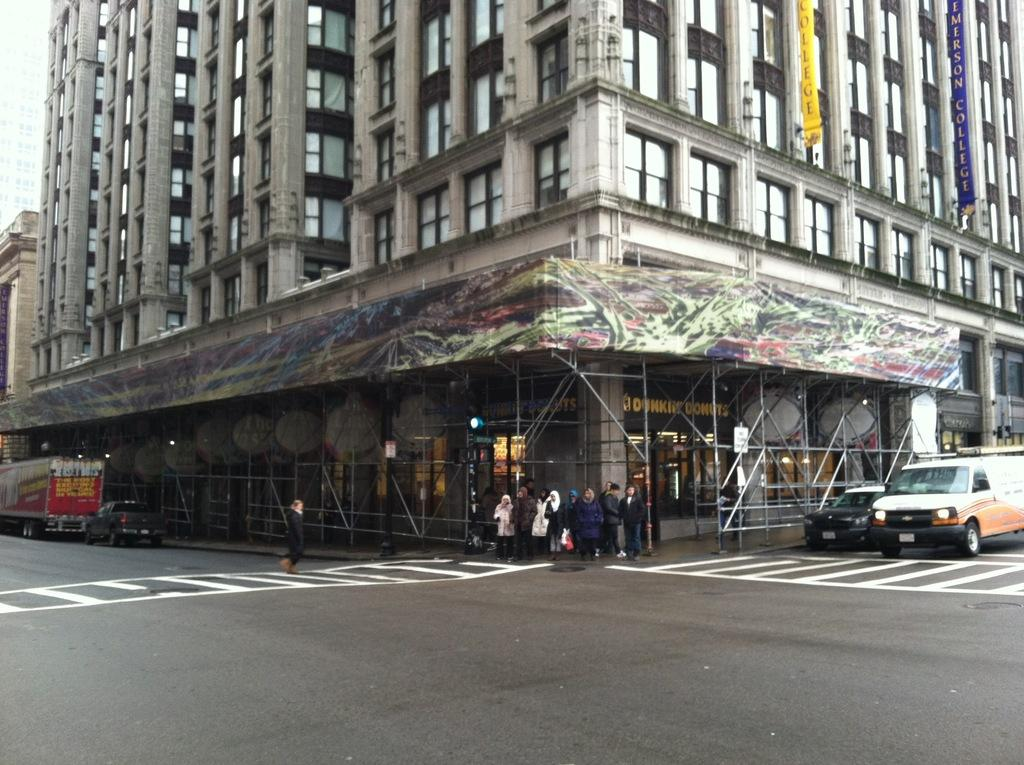What is the main structure in the image? There is a building in the image. What feature can be seen on the building? The building has windows. What is happening on the road in the image? There are vehicles on the road, and people are standing near them. What type of milk is being spilled by the people standing near the vehicles on the road? There is no milk present in the image, and no one is spilling anything. 